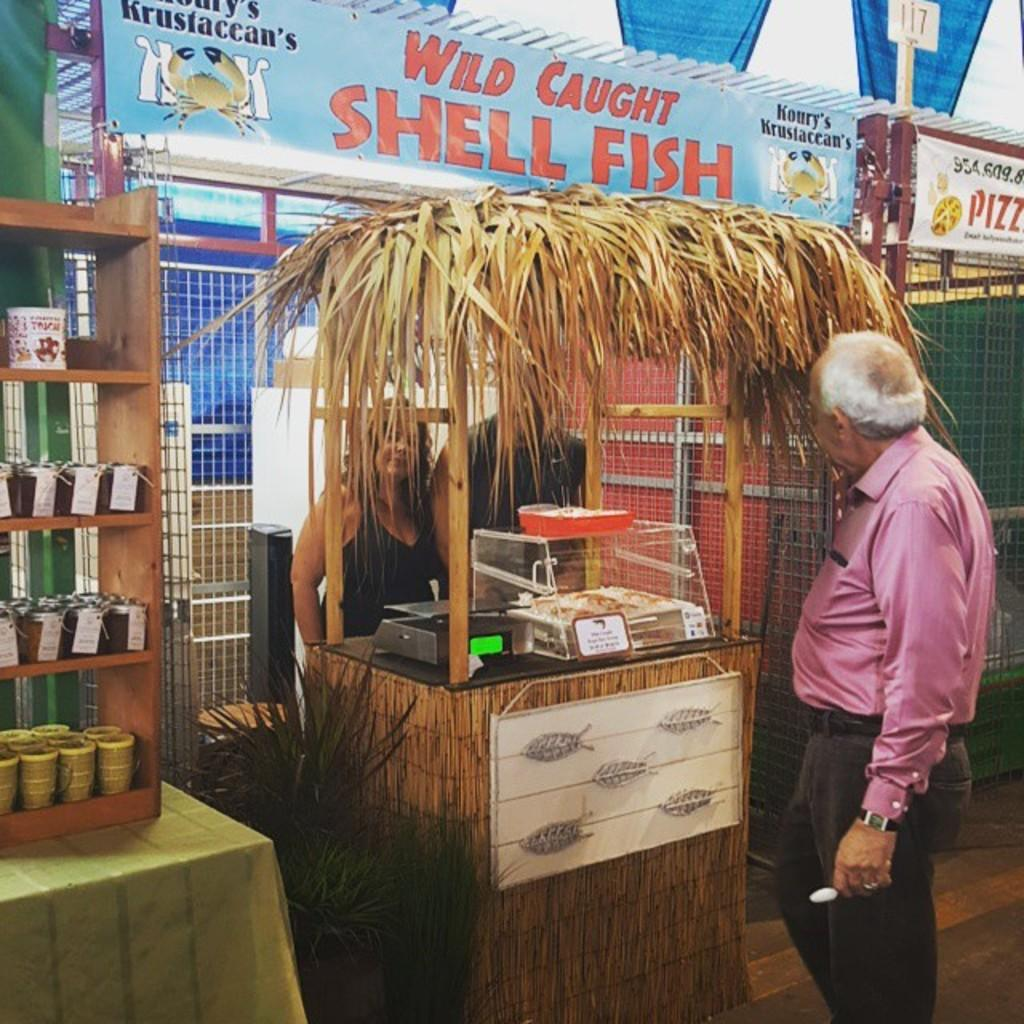<image>
Present a compact description of the photo's key features. a man with a wild caught shell fish sign 